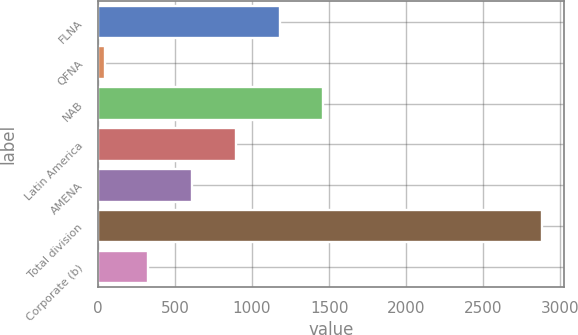Convert chart. <chart><loc_0><loc_0><loc_500><loc_500><bar_chart><fcel>FLNA<fcel>QFNA<fcel>NAB<fcel>Latin America<fcel>AMENA<fcel>Total division<fcel>Corporate (b)<nl><fcel>1179.6<fcel>44<fcel>1463.5<fcel>895.7<fcel>611.8<fcel>2883<fcel>327.9<nl></chart> 